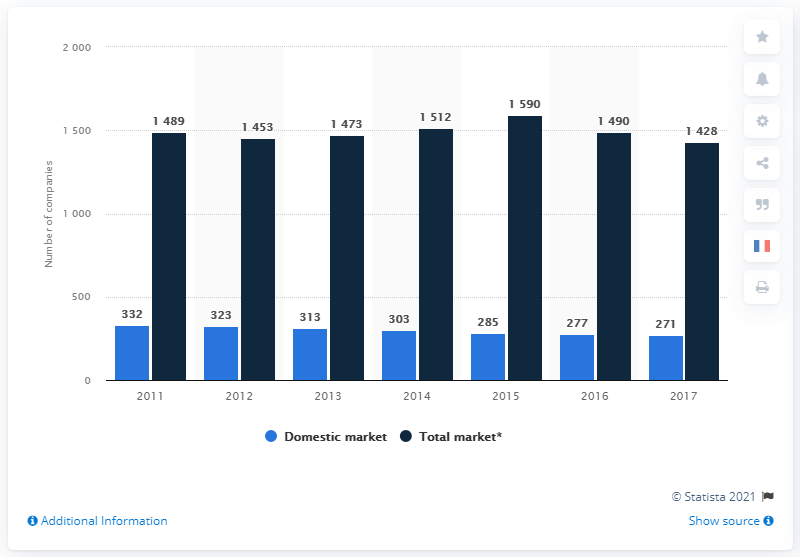Indicate a few pertinent items in this graphic. In 2017, there were 271 domestic insurance companies in the United States. 